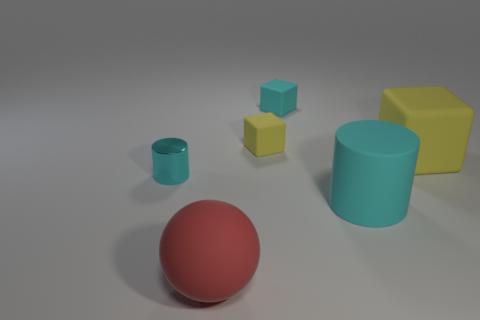Add 1 big cyan rubber cylinders. How many objects exist? 7 Subtract all spheres. How many objects are left? 5 Add 6 big red balls. How many big red balls are left? 7 Add 4 matte things. How many matte things exist? 9 Subtract 0 blue cylinders. How many objects are left? 6 Subtract all big yellow blocks. Subtract all cyan metal things. How many objects are left? 4 